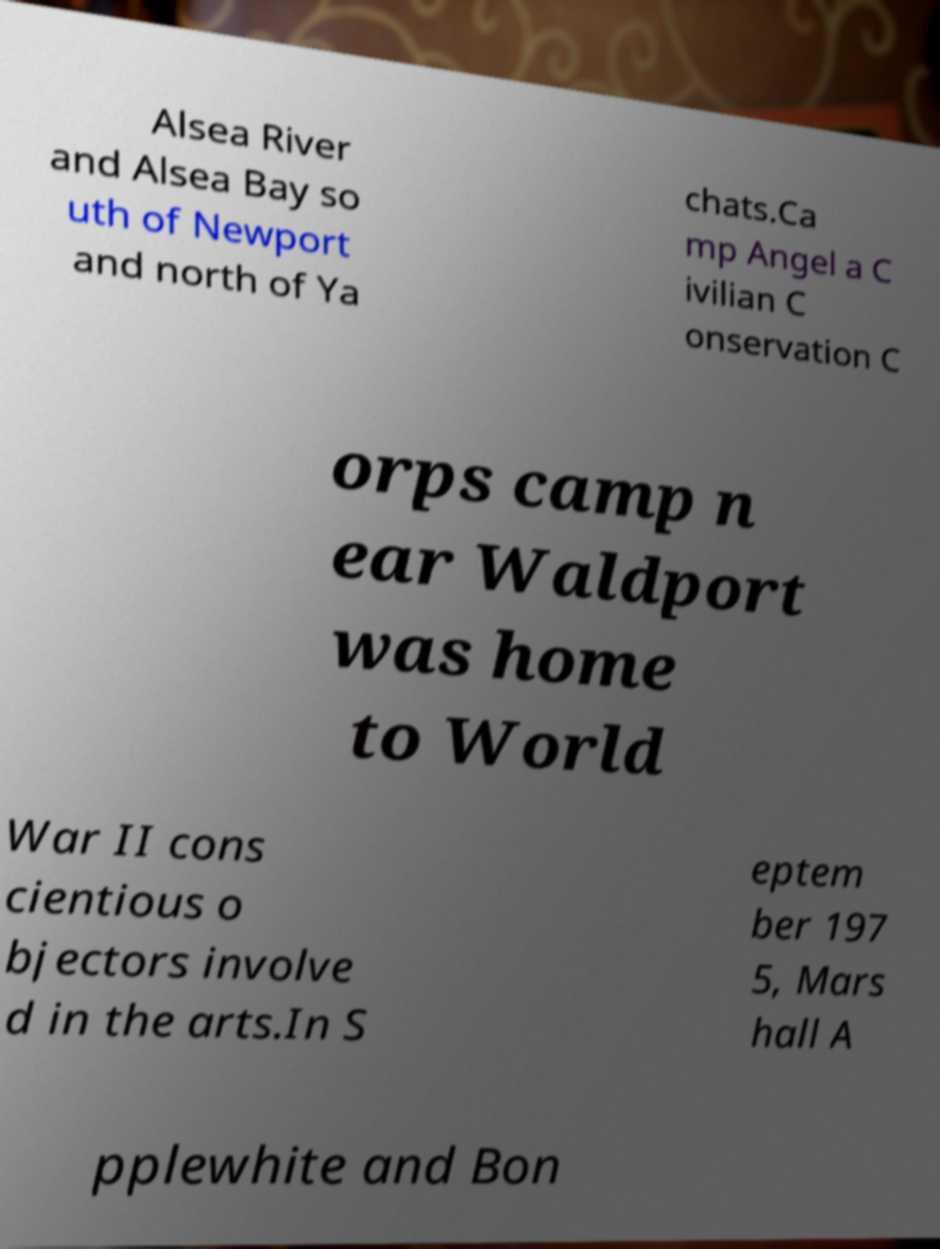Could you assist in decoding the text presented in this image and type it out clearly? Alsea River and Alsea Bay so uth of Newport and north of Ya chats.Ca mp Angel a C ivilian C onservation C orps camp n ear Waldport was home to World War II cons cientious o bjectors involve d in the arts.In S eptem ber 197 5, Mars hall A pplewhite and Bon 